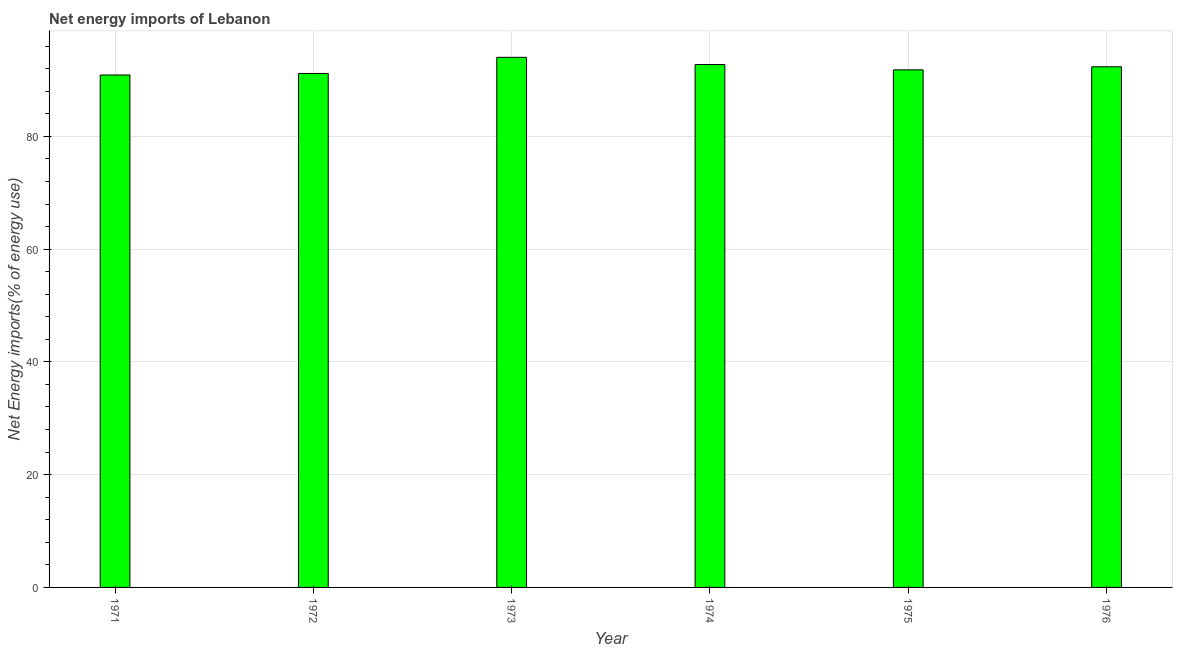What is the title of the graph?
Your answer should be compact. Net energy imports of Lebanon. What is the label or title of the X-axis?
Your response must be concise. Year. What is the label or title of the Y-axis?
Offer a terse response. Net Energy imports(% of energy use). What is the energy imports in 1974?
Provide a succinct answer. 92.74. Across all years, what is the maximum energy imports?
Provide a short and direct response. 94.02. Across all years, what is the minimum energy imports?
Your response must be concise. 90.88. In which year was the energy imports minimum?
Ensure brevity in your answer.  1971. What is the sum of the energy imports?
Keep it short and to the point. 552.93. What is the difference between the energy imports in 1971 and 1976?
Ensure brevity in your answer.  -1.46. What is the average energy imports per year?
Provide a succinct answer. 92.16. What is the median energy imports?
Keep it short and to the point. 92.07. Do a majority of the years between 1975 and 1974 (inclusive) have energy imports greater than 44 %?
Your answer should be compact. No. Is the energy imports in 1973 less than that in 1974?
Provide a short and direct response. No. Is the difference between the energy imports in 1972 and 1974 greater than the difference between any two years?
Keep it short and to the point. No. What is the difference between the highest and the second highest energy imports?
Provide a short and direct response. 1.28. Is the sum of the energy imports in 1971 and 1973 greater than the maximum energy imports across all years?
Your answer should be very brief. Yes. What is the difference between the highest and the lowest energy imports?
Your answer should be very brief. 3.13. How many bars are there?
Your answer should be compact. 6. How many years are there in the graph?
Make the answer very short. 6. What is the difference between two consecutive major ticks on the Y-axis?
Offer a very short reply. 20. What is the Net Energy imports(% of energy use) in 1971?
Your answer should be very brief. 90.88. What is the Net Energy imports(% of energy use) in 1972?
Offer a very short reply. 91.16. What is the Net Energy imports(% of energy use) in 1973?
Ensure brevity in your answer.  94.02. What is the Net Energy imports(% of energy use) of 1974?
Your answer should be compact. 92.74. What is the Net Energy imports(% of energy use) of 1975?
Ensure brevity in your answer.  91.8. What is the Net Energy imports(% of energy use) in 1976?
Provide a succinct answer. 92.34. What is the difference between the Net Energy imports(% of energy use) in 1971 and 1972?
Provide a short and direct response. -0.27. What is the difference between the Net Energy imports(% of energy use) in 1971 and 1973?
Your answer should be compact. -3.13. What is the difference between the Net Energy imports(% of energy use) in 1971 and 1974?
Your response must be concise. -1.85. What is the difference between the Net Energy imports(% of energy use) in 1971 and 1975?
Offer a terse response. -0.91. What is the difference between the Net Energy imports(% of energy use) in 1971 and 1976?
Make the answer very short. -1.46. What is the difference between the Net Energy imports(% of energy use) in 1972 and 1973?
Offer a very short reply. -2.86. What is the difference between the Net Energy imports(% of energy use) in 1972 and 1974?
Your answer should be very brief. -1.58. What is the difference between the Net Energy imports(% of energy use) in 1972 and 1975?
Give a very brief answer. -0.64. What is the difference between the Net Energy imports(% of energy use) in 1972 and 1976?
Offer a terse response. -1.18. What is the difference between the Net Energy imports(% of energy use) in 1973 and 1974?
Your answer should be compact. 1.28. What is the difference between the Net Energy imports(% of energy use) in 1973 and 1975?
Your answer should be very brief. 2.22. What is the difference between the Net Energy imports(% of energy use) in 1973 and 1976?
Offer a terse response. 1.68. What is the difference between the Net Energy imports(% of energy use) in 1974 and 1975?
Give a very brief answer. 0.94. What is the difference between the Net Energy imports(% of energy use) in 1974 and 1976?
Your answer should be very brief. 0.4. What is the difference between the Net Energy imports(% of energy use) in 1975 and 1976?
Give a very brief answer. -0.54. What is the ratio of the Net Energy imports(% of energy use) in 1971 to that in 1972?
Provide a succinct answer. 1. What is the ratio of the Net Energy imports(% of energy use) in 1971 to that in 1973?
Make the answer very short. 0.97. What is the ratio of the Net Energy imports(% of energy use) in 1971 to that in 1974?
Offer a very short reply. 0.98. What is the ratio of the Net Energy imports(% of energy use) in 1971 to that in 1975?
Offer a very short reply. 0.99. What is the ratio of the Net Energy imports(% of energy use) in 1973 to that in 1975?
Offer a very short reply. 1.02. 